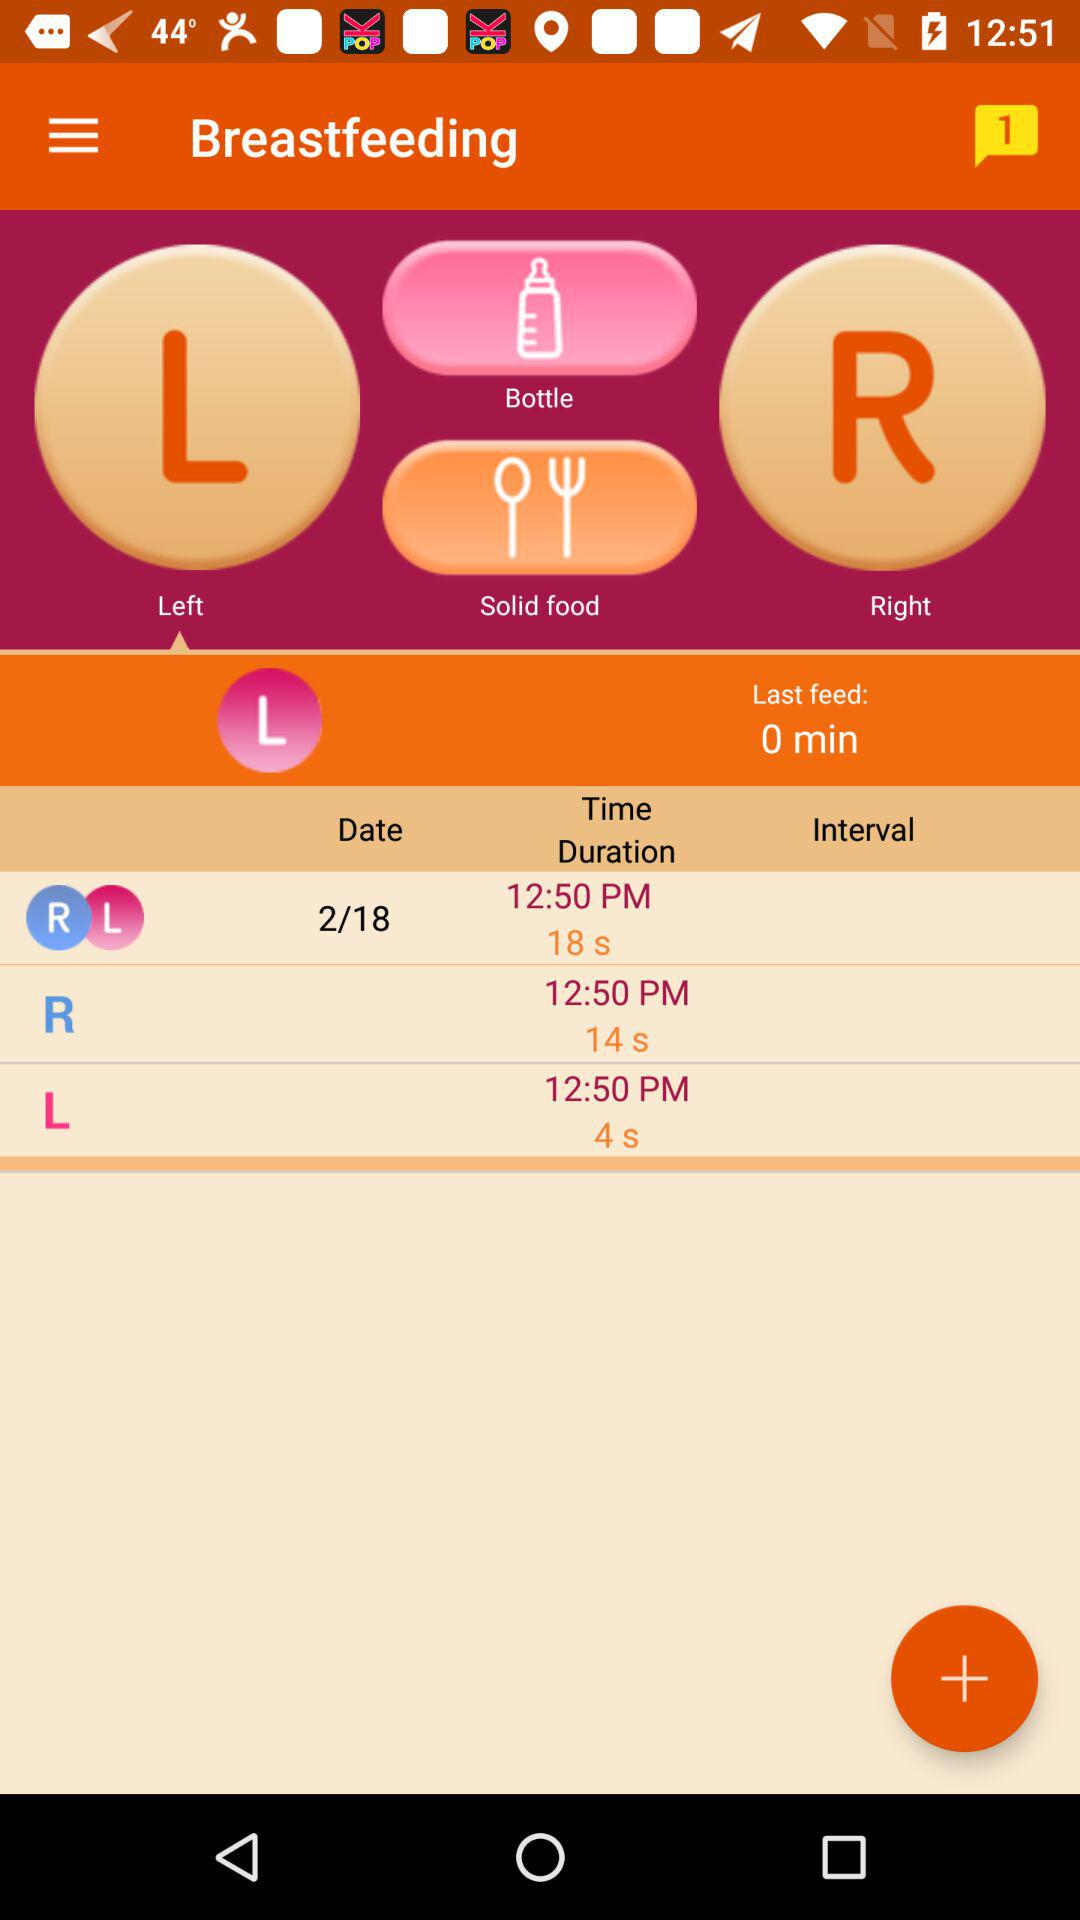Is there any unread chat?
When the provided information is insufficient, respond with <no answer>. <no answer> 